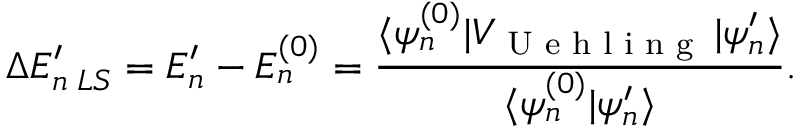Convert formula to latex. <formula><loc_0><loc_0><loc_500><loc_500>\Delta E _ { n \, L S } ^ { \prime } = E _ { n } ^ { \prime } - E _ { n } ^ { ( 0 ) } = \frac { \langle \psi _ { n } ^ { ( 0 ) } | V _ { U e h l i n g } \, | \psi _ { n } ^ { \prime } \rangle } { \langle \psi _ { n } ^ { ( 0 ) } | \psi _ { n } ^ { \prime } \rangle } .</formula> 